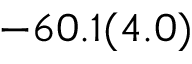<formula> <loc_0><loc_0><loc_500><loc_500>- 6 0 . 1 ( 4 . 0 )</formula> 